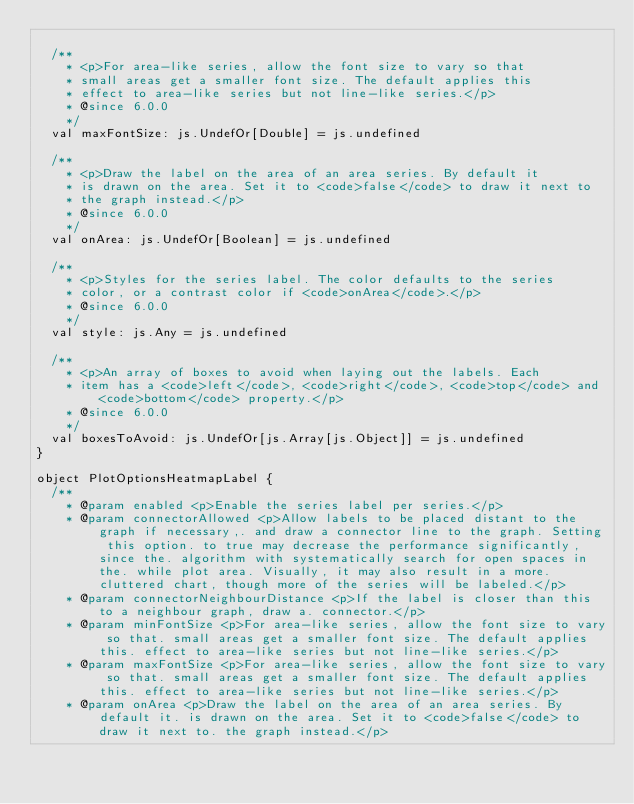Convert code to text. <code><loc_0><loc_0><loc_500><loc_500><_Scala_>
  /**
    * <p>For area-like series, allow the font size to vary so that
    * small areas get a smaller font size. The default applies this
    * effect to area-like series but not line-like series.</p>
    * @since 6.0.0
    */
  val maxFontSize: js.UndefOr[Double] = js.undefined

  /**
    * <p>Draw the label on the area of an area series. By default it
    * is drawn on the area. Set it to <code>false</code> to draw it next to
    * the graph instead.</p>
    * @since 6.0.0
    */
  val onArea: js.UndefOr[Boolean] = js.undefined

  /**
    * <p>Styles for the series label. The color defaults to the series
    * color, or a contrast color if <code>onArea</code>.</p>
    * @since 6.0.0
    */
  val style: js.Any = js.undefined

  /**
    * <p>An array of boxes to avoid when laying out the labels. Each
    * item has a <code>left</code>, <code>right</code>, <code>top</code> and <code>bottom</code> property.</p>
    * @since 6.0.0
    */
  val boxesToAvoid: js.UndefOr[js.Array[js.Object]] = js.undefined
}

object PlotOptionsHeatmapLabel {
  /**
    * @param enabled <p>Enable the series label per series.</p>
    * @param connectorAllowed <p>Allow labels to be placed distant to the graph if necessary,. and draw a connector line to the graph. Setting this option. to true may decrease the performance significantly, since the. algorithm with systematically search for open spaces in the. while plot area. Visually, it may also result in a more. cluttered chart, though more of the series will be labeled.</p>
    * @param connectorNeighbourDistance <p>If the label is closer than this to a neighbour graph, draw a. connector.</p>
    * @param minFontSize <p>For area-like series, allow the font size to vary so that. small areas get a smaller font size. The default applies this. effect to area-like series but not line-like series.</p>
    * @param maxFontSize <p>For area-like series, allow the font size to vary so that. small areas get a smaller font size. The default applies this. effect to area-like series but not line-like series.</p>
    * @param onArea <p>Draw the label on the area of an area series. By default it. is drawn on the area. Set it to <code>false</code> to draw it next to. the graph instead.</p></code> 